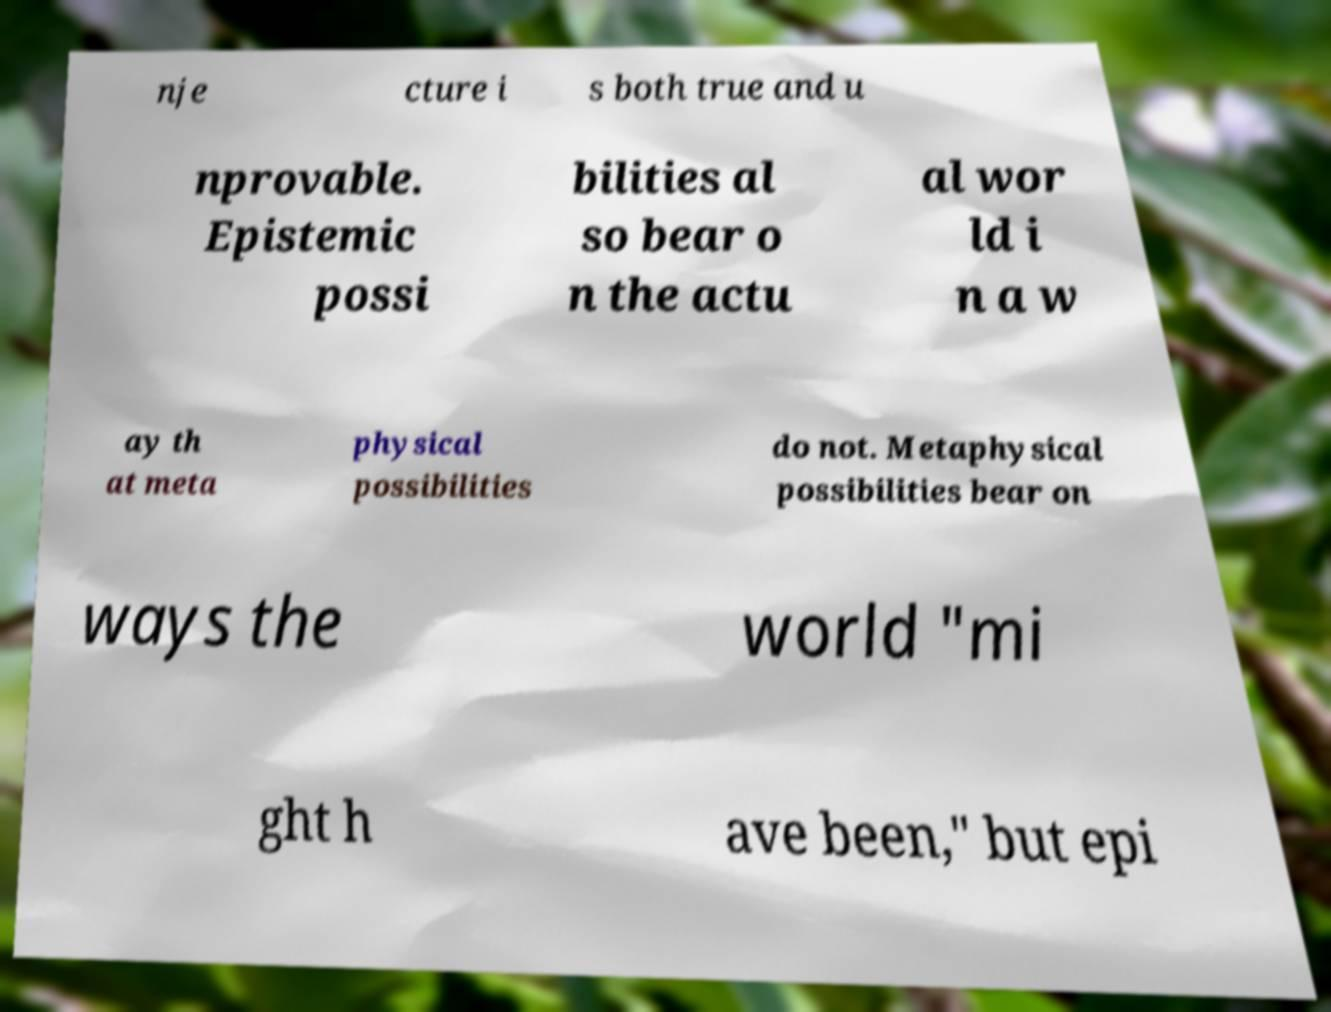Can you accurately transcribe the text from the provided image for me? nje cture i s both true and u nprovable. Epistemic possi bilities al so bear o n the actu al wor ld i n a w ay th at meta physical possibilities do not. Metaphysical possibilities bear on ways the world "mi ght h ave been," but epi 